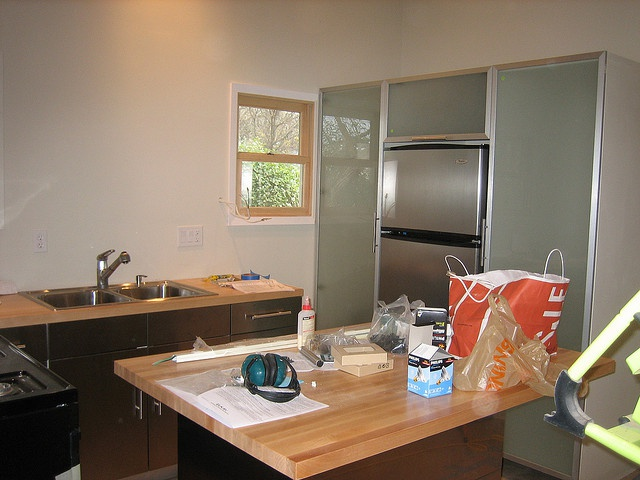Describe the objects in this image and their specific colors. I can see refrigerator in gray, black, and darkgray tones, oven in gray and black tones, handbag in gray, red, brown, and lightgray tones, sink in gray, maroon, and black tones, and bottle in gray, tan, and lightgray tones in this image. 